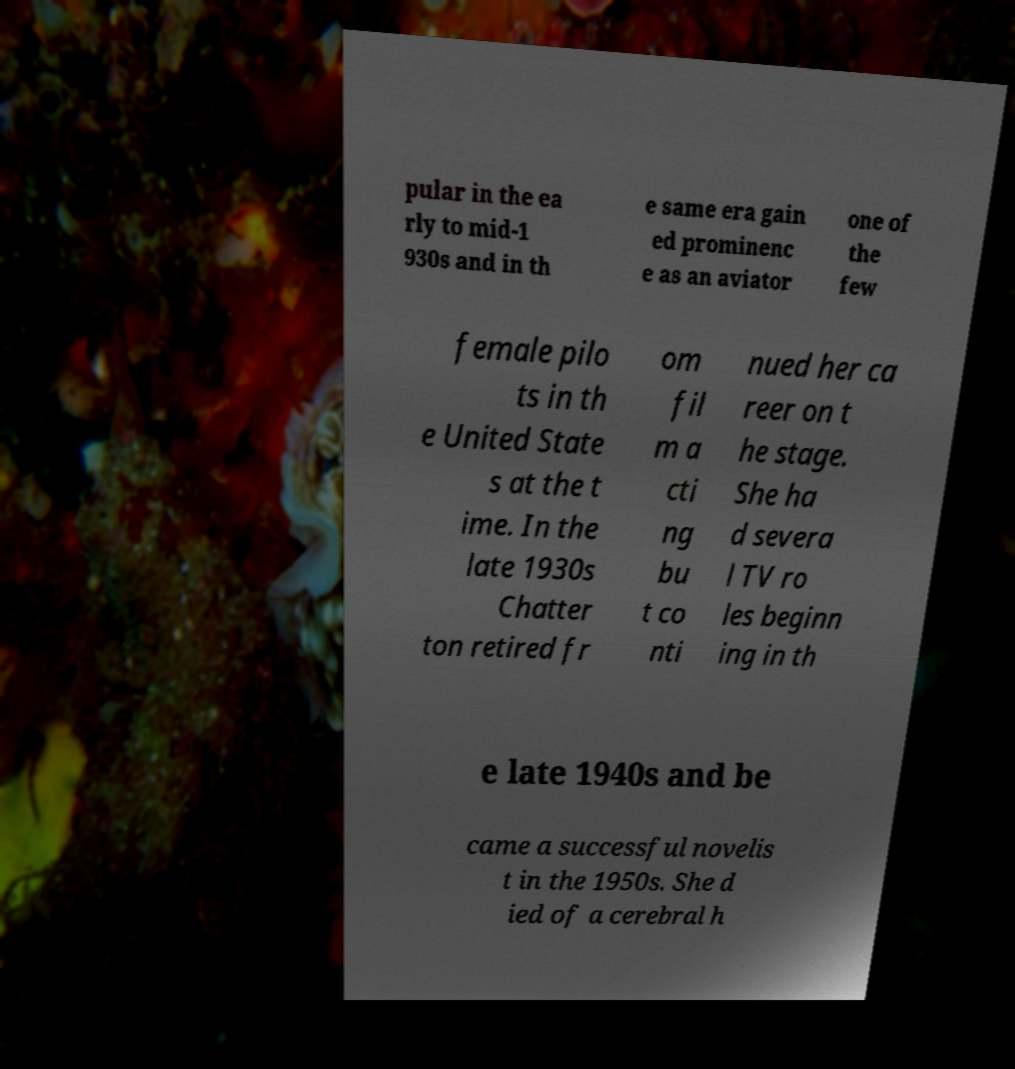Please identify and transcribe the text found in this image. pular in the ea rly to mid-1 930s and in th e same era gain ed prominenc e as an aviator one of the few female pilo ts in th e United State s at the t ime. In the late 1930s Chatter ton retired fr om fil m a cti ng bu t co nti nued her ca reer on t he stage. She ha d severa l TV ro les beginn ing in th e late 1940s and be came a successful novelis t in the 1950s. She d ied of a cerebral h 